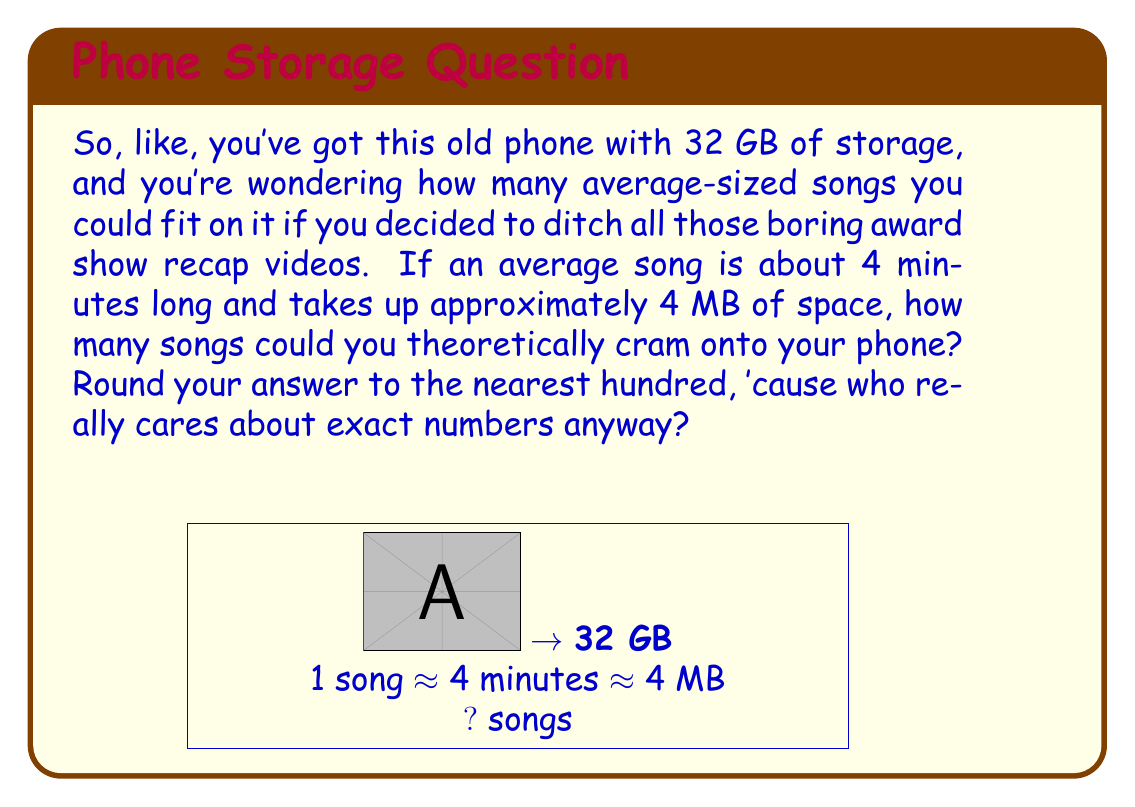Provide a solution to this math problem. Alright, let's break this down:

1) First, we need to convert the phone's storage from GB to MB:
   $32 \text{ GB} = 32 \times 1024 \text{ MB} = 32,768 \text{ MB}$

2) Now, we know each song takes up about 4 MB. So to find the number of songs, we divide the total storage by the size of each song:

   $$\text{Number of songs} = \frac{\text{Total storage}}{\text{Size per song}} = \frac{32,768 \text{ MB}}{4 \text{ MB/song}}$$

3) Let's do that division:
   $$\frac{32,768}{4} = 8,192 \text{ songs}$$

4) The question asks to round to the nearest hundred, so:
   8,192 rounds to 8,200 songs

5) Just to double-check our logic: 
   $8,200 \text{ songs} \times 4 \text{ MB/song} = 32,800 \text{ MB}$
   Which is pretty close to our original 32,768 MB, so we're good.
Answer: 8,200 songs 